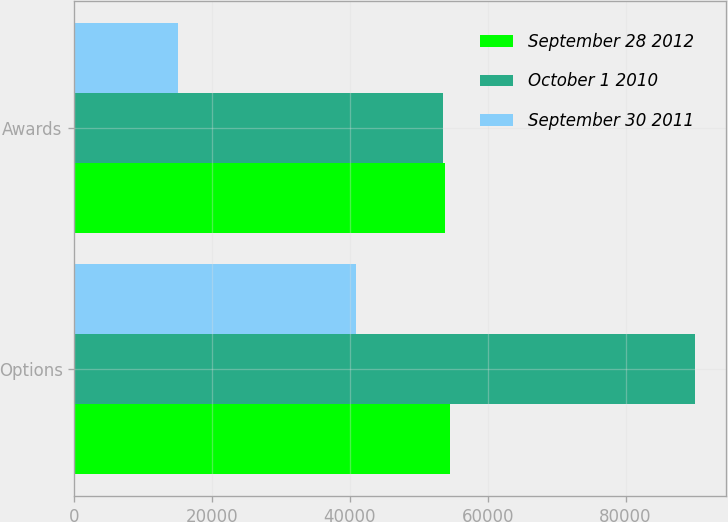Convert chart to OTSL. <chart><loc_0><loc_0><loc_500><loc_500><stacked_bar_chart><ecel><fcel>Options<fcel>Awards<nl><fcel>September 28 2012<fcel>54460<fcel>53759<nl><fcel>October 1 2010<fcel>90062<fcel>53569<nl><fcel>September 30 2011<fcel>40837<fcel>15030<nl></chart> 